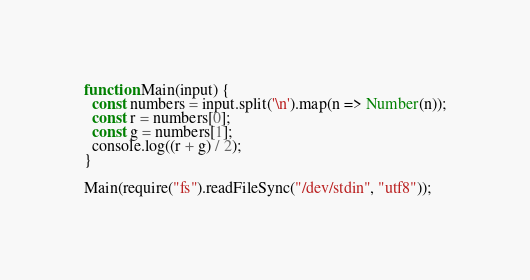<code> <loc_0><loc_0><loc_500><loc_500><_JavaScript_>function Main(input) {
  const numbers = input.split('\n').map(n => Number(n));
  const r = numbers[0];
  const g = numbers[1];
  console.log((r + g) / 2);
}

Main(require("fs").readFileSync("/dev/stdin", "utf8"));</code> 